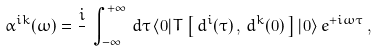<formula> <loc_0><loc_0><loc_500><loc_500>\alpha ^ { i k } ( \omega ) = \frac { i } { } \, \int _ { - \infty } ^ { + \infty } \, { d \tau } \, \langle 0 | T \left [ \, d ^ { i } ( \tau ) \, , \, d ^ { k } ( 0 ) \, \right ] | 0 \rangle \, e ^ { + i \omega \tau } \, ,</formula> 